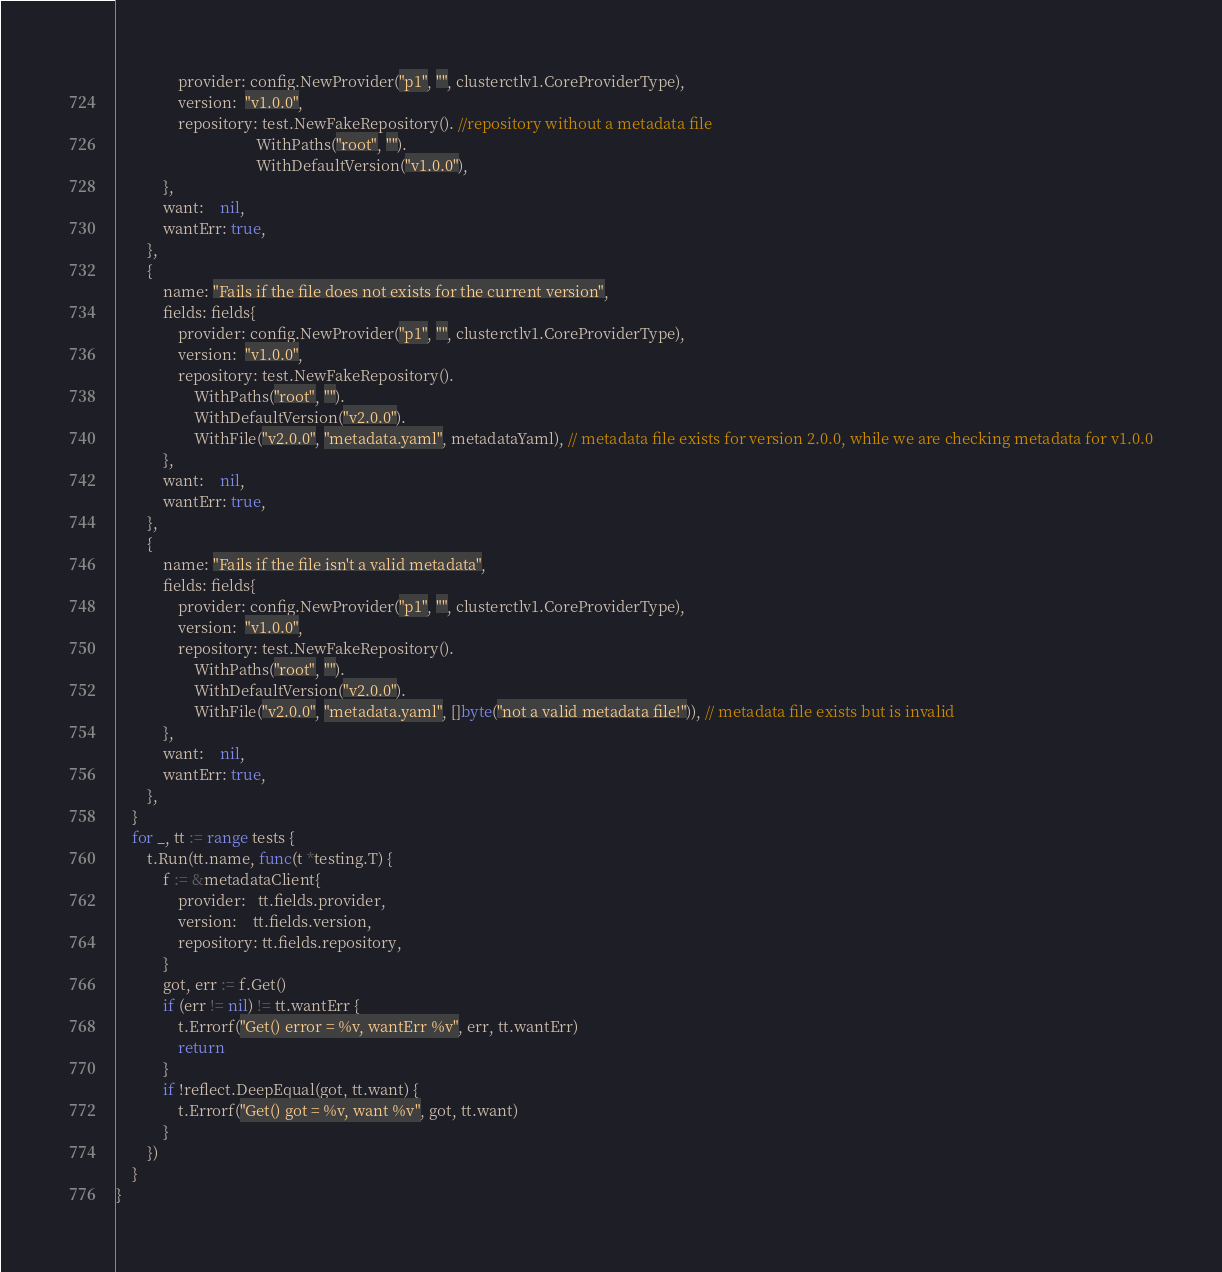Convert code to text. <code><loc_0><loc_0><loc_500><loc_500><_Go_>				provider: config.NewProvider("p1", "", clusterctlv1.CoreProviderType),
				version:  "v1.0.0",
				repository: test.NewFakeRepository(). //repository without a metadata file
									WithPaths("root", "").
									WithDefaultVersion("v1.0.0"),
			},
			want:    nil,
			wantErr: true,
		},
		{
			name: "Fails if the file does not exists for the current version",
			fields: fields{
				provider: config.NewProvider("p1", "", clusterctlv1.CoreProviderType),
				version:  "v1.0.0",
				repository: test.NewFakeRepository().
					WithPaths("root", "").
					WithDefaultVersion("v2.0.0").
					WithFile("v2.0.0", "metadata.yaml", metadataYaml), // metadata file exists for version 2.0.0, while we are checking metadata for v1.0.0
			},
			want:    nil,
			wantErr: true,
		},
		{
			name: "Fails if the file isn't a valid metadata",
			fields: fields{
				provider: config.NewProvider("p1", "", clusterctlv1.CoreProviderType),
				version:  "v1.0.0",
				repository: test.NewFakeRepository().
					WithPaths("root", "").
					WithDefaultVersion("v2.0.0").
					WithFile("v2.0.0", "metadata.yaml", []byte("not a valid metadata file!")), // metadata file exists but is invalid
			},
			want:    nil,
			wantErr: true,
		},
	}
	for _, tt := range tests {
		t.Run(tt.name, func(t *testing.T) {
			f := &metadataClient{
				provider:   tt.fields.provider,
				version:    tt.fields.version,
				repository: tt.fields.repository,
			}
			got, err := f.Get()
			if (err != nil) != tt.wantErr {
				t.Errorf("Get() error = %v, wantErr %v", err, tt.wantErr)
				return
			}
			if !reflect.DeepEqual(got, tt.want) {
				t.Errorf("Get() got = %v, want %v", got, tt.want)
			}
		})
	}
}
</code> 